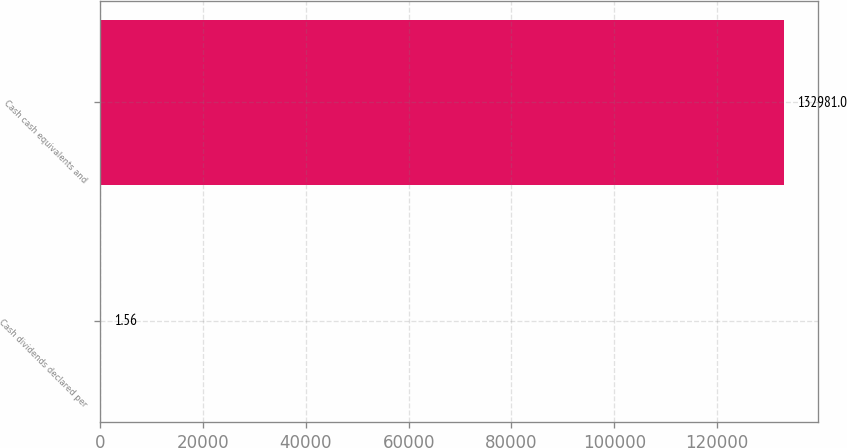<chart> <loc_0><loc_0><loc_500><loc_500><bar_chart><fcel>Cash dividends declared per<fcel>Cash cash equivalents and<nl><fcel>1.56<fcel>132981<nl></chart> 